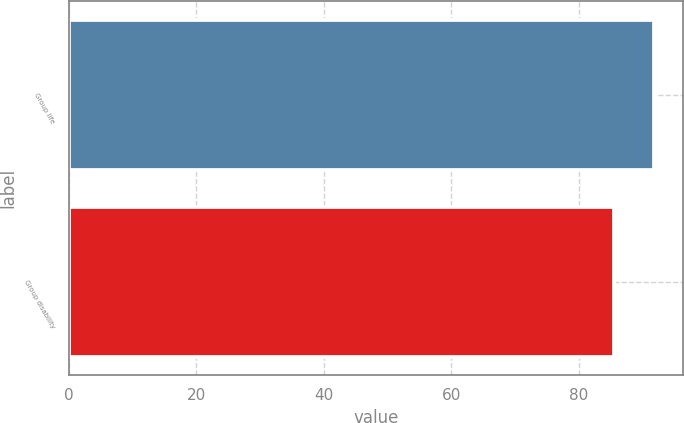Convert chart. <chart><loc_0><loc_0><loc_500><loc_500><bar_chart><fcel>Group life<fcel>Group disability<nl><fcel>91.8<fcel>85.5<nl></chart> 